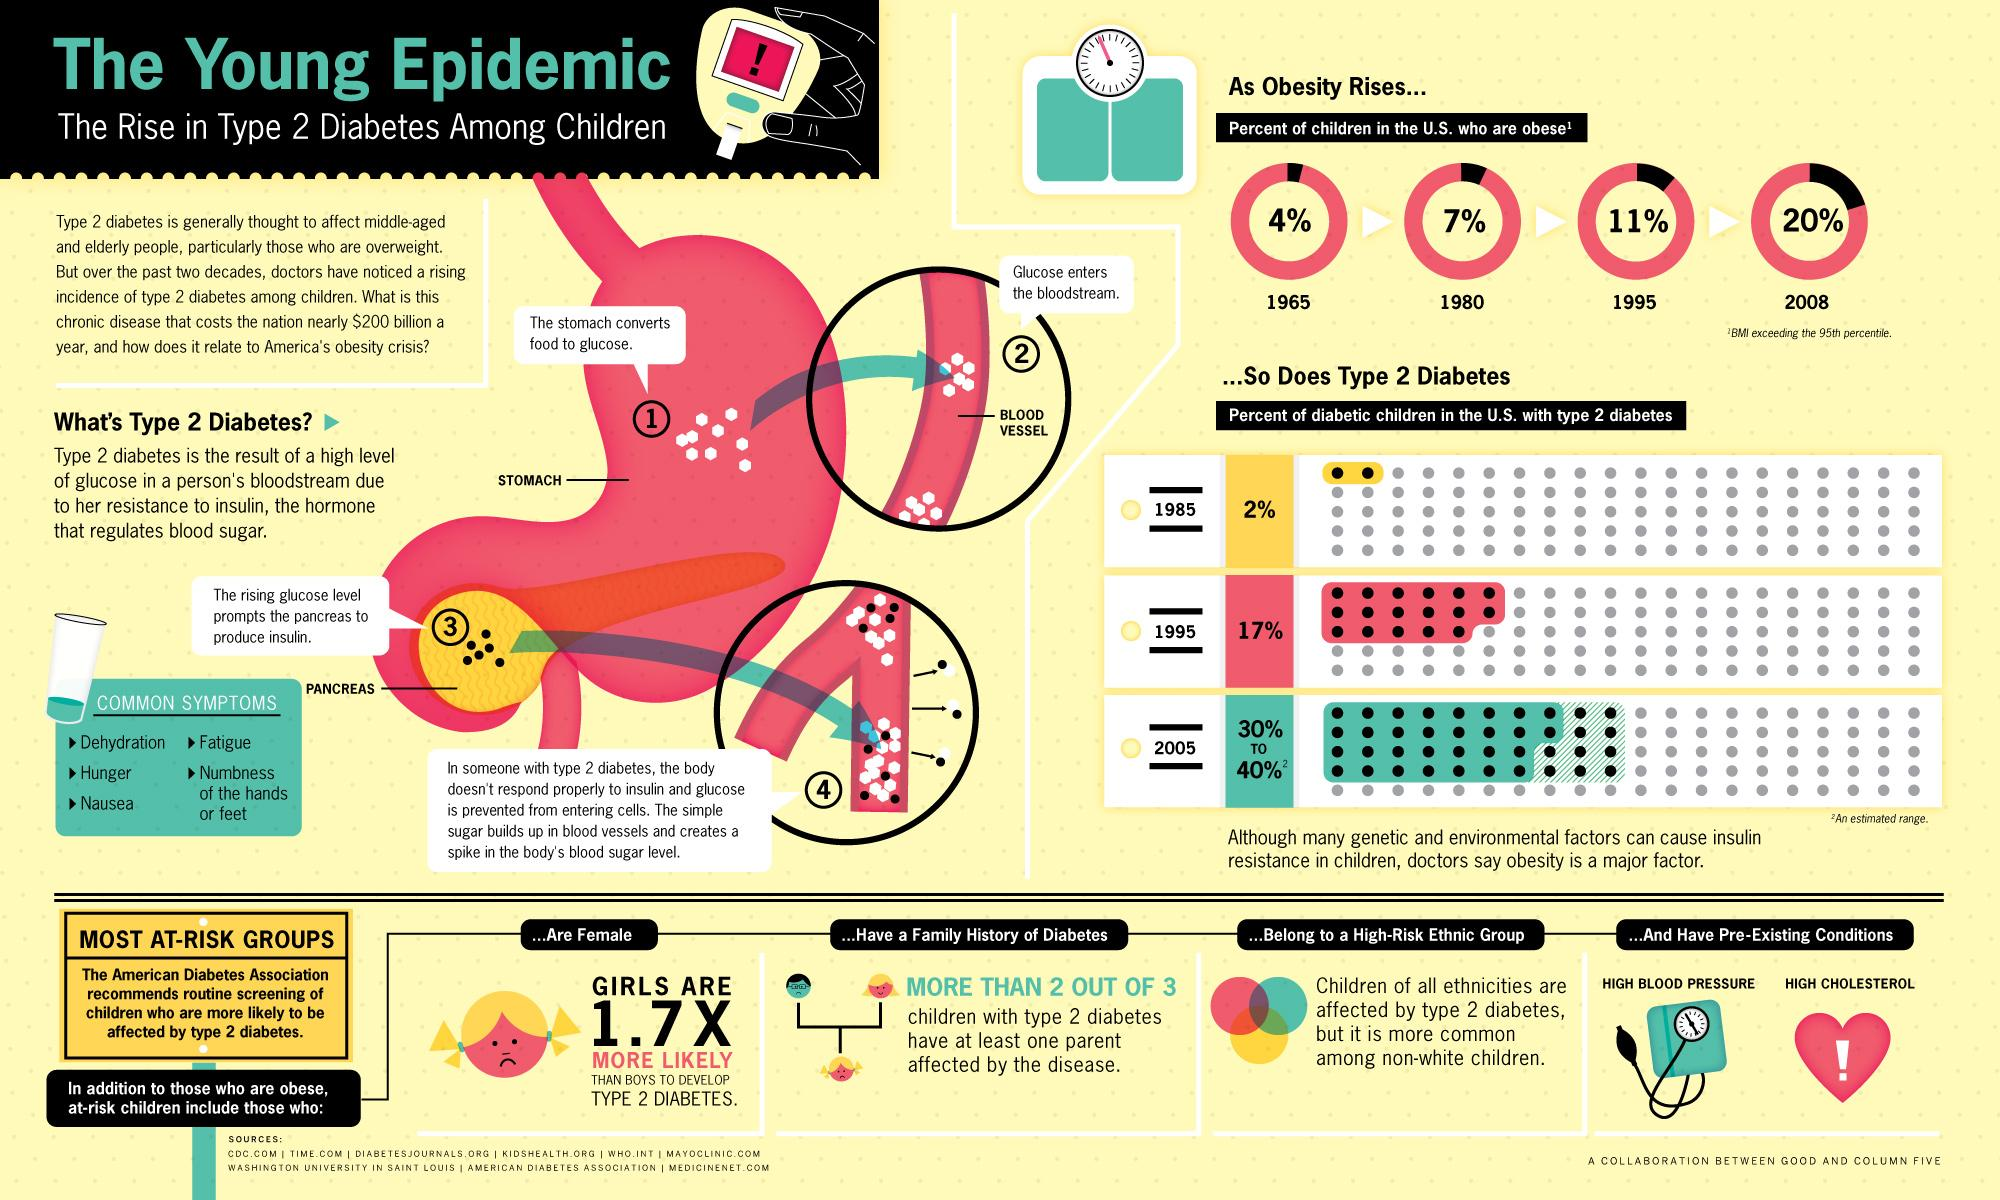Mention a couple of crucial points in this snapshot. In 2008, it was estimated that approximately 20% of children in the United States were obese. A study has found that non-white children in the U.S. are more likely to develop type 2 diabetes compared to children of other ethnic backgrounds. High blood pressure and high cholesterol are pre-existing conditions that can increase the risk of developing type 2 diabetes in children. Insulin, a hormone essential for regulating blood sugar levels, is produced by the pancreas in the human body. In 1995, it was reported that approximately 11% of children in the United States were obese. 